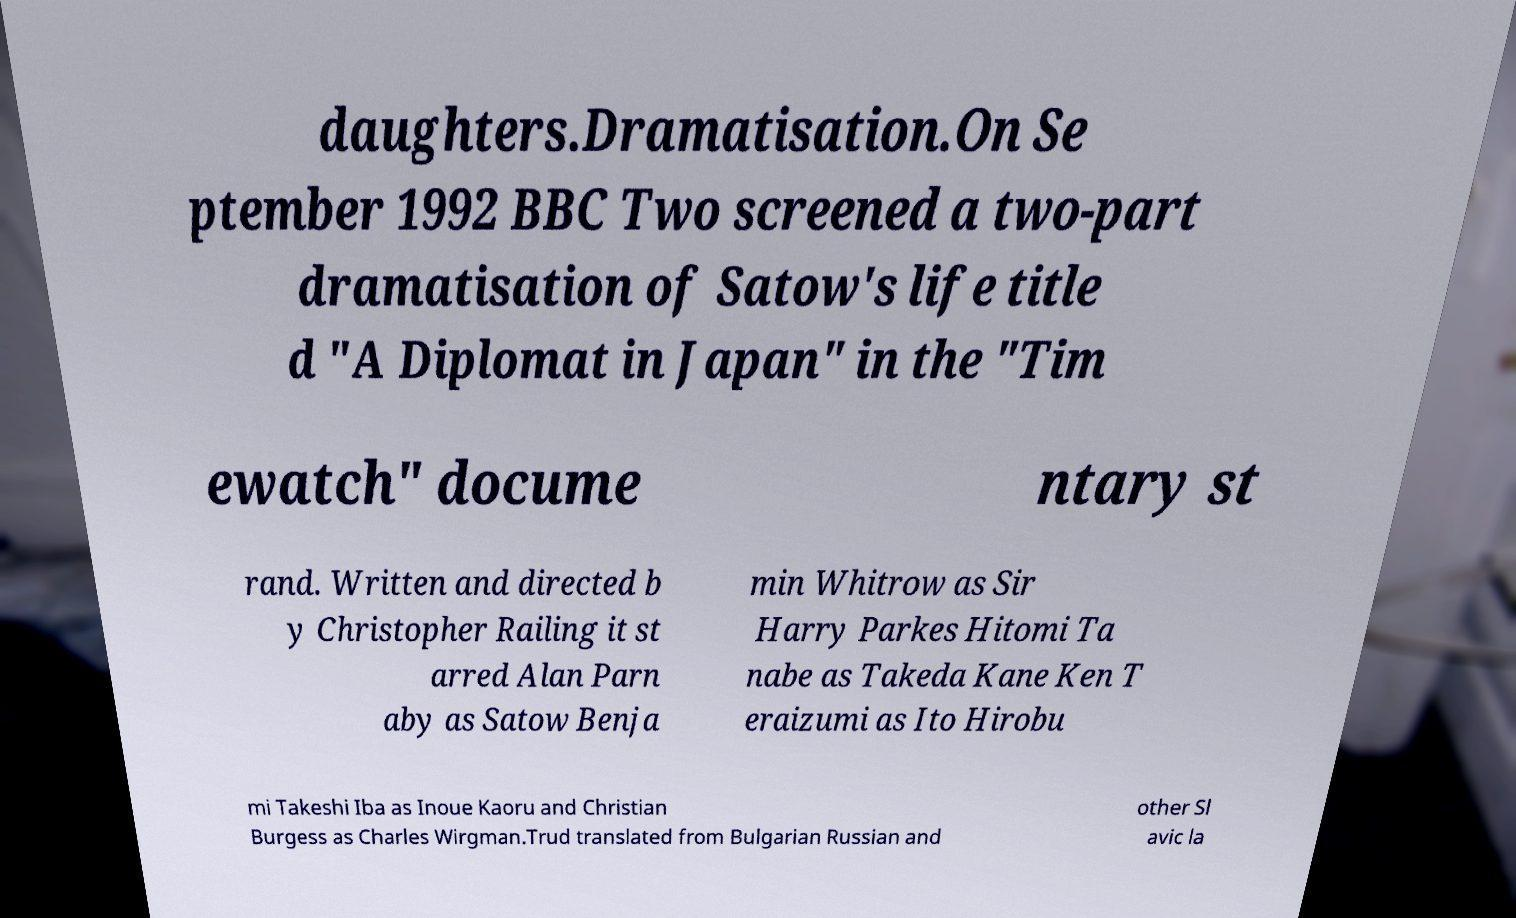Could you assist in decoding the text presented in this image and type it out clearly? daughters.Dramatisation.On Se ptember 1992 BBC Two screened a two-part dramatisation of Satow's life title d "A Diplomat in Japan" in the "Tim ewatch" docume ntary st rand. Written and directed b y Christopher Railing it st arred Alan Parn aby as Satow Benja min Whitrow as Sir Harry Parkes Hitomi Ta nabe as Takeda Kane Ken T eraizumi as Ito Hirobu mi Takeshi Iba as Inoue Kaoru and Christian Burgess as Charles Wirgman.Trud translated from Bulgarian Russian and other Sl avic la 